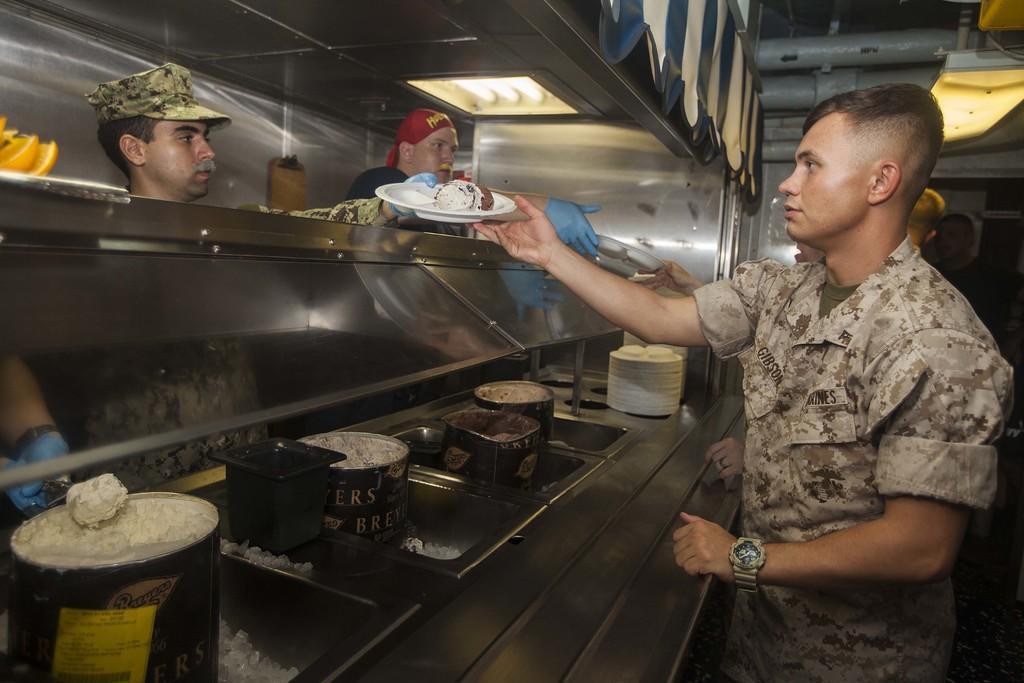In one or two sentences, can you explain what this image depicts? In this image we can see group of persons standing, some persons are wearing military uniforms, one person is wearing cap and holding a plate containing food. In the foreground we can see containers and bowls containing food and some plates placed on the table. To the left side of the image we can see some fruits placed on the surface. In the background, we can see group of lights, poles and a sheet. 